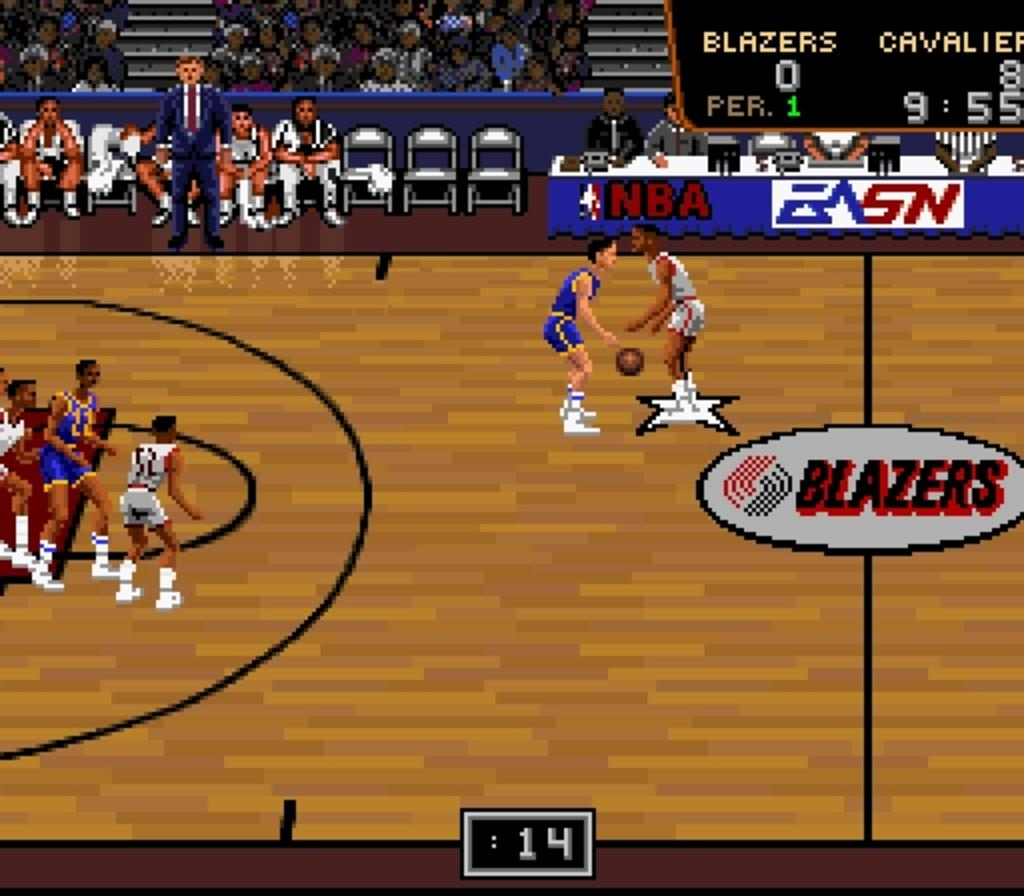What is depicted in the image? There is a drawing of people in the image. What type of furniture is present in the image? There are chairs in the image. What object can be seen in the image that is typically used for playing? There is a ball in the image. What piece of furniture is commonly used for placing objects on or eating at? There is a table in the image. What type of suit is the person wearing in the image? There are no people wearing suits in the image, as it only contains a drawing of people. How many snakes are slithering across the table in the image? There are no snakes present in the image; it only contains a drawing of people, chairs, a ball, and a table. 